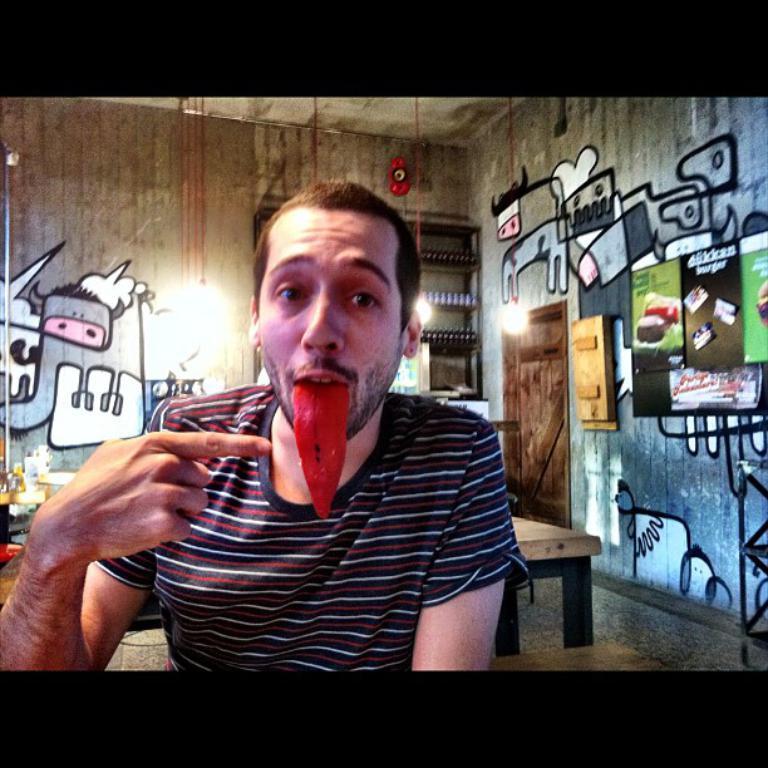How would you summarize this image in a sentence or two? In this image in front there is a person. Behind him there is a table. On the left side of the image there are a few objects. On the right side of the image there is a wooden door. There are photo frames attached to the wall. In the background of the image there are lights. There are bottles placed on the rack. There is a painting on the wall. At the bottom of the image there is a floor. 